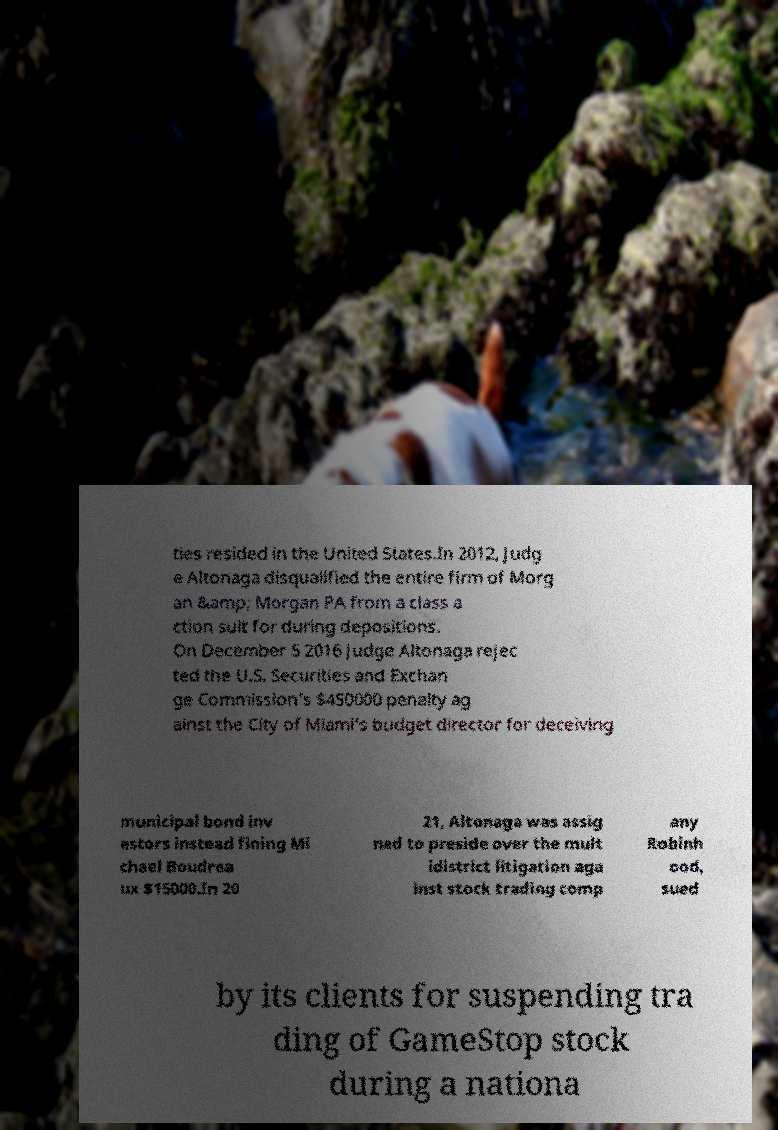I need the written content from this picture converted into text. Can you do that? ties resided in the United States.In 2012, Judg e Altonaga disqualified the entire firm of Morg an &amp; Morgan PA from a class a ction suit for during depositions. On December 5 2016 Judge Altonaga rejec ted the U.S. Securities and Exchan ge Commission’s $450000 penalty ag ainst the City of Miami’s budget director for deceiving municipal bond inv estors instead fining Mi chael Boudrea ux $15000.In 20 21, Altonaga was assig ned to preside over the mult idistrict litigation aga inst stock trading comp any Robinh ood, sued by its clients for suspending tra ding of GameStop stock during a nationa 